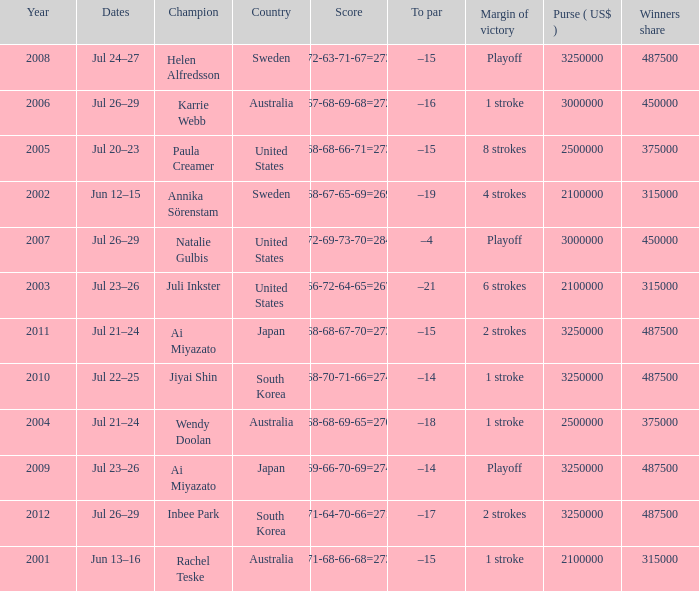How many dollars is the purse when the margin of victory is 8 strokes? 1.0. 